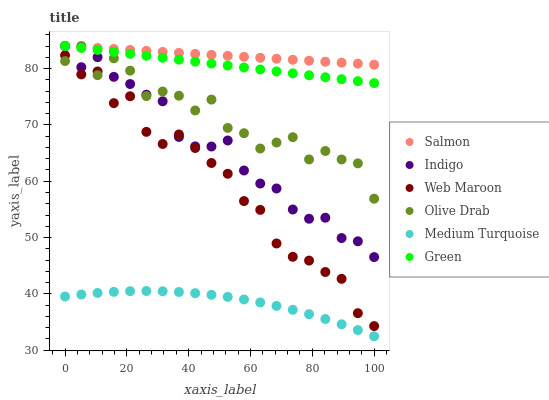Does Medium Turquoise have the minimum area under the curve?
Answer yes or no. Yes. Does Salmon have the maximum area under the curve?
Answer yes or no. Yes. Does Web Maroon have the minimum area under the curve?
Answer yes or no. No. Does Web Maroon have the maximum area under the curve?
Answer yes or no. No. Is Salmon the smoothest?
Answer yes or no. Yes. Is Olive Drab the roughest?
Answer yes or no. Yes. Is Web Maroon the smoothest?
Answer yes or no. No. Is Web Maroon the roughest?
Answer yes or no. No. Does Medium Turquoise have the lowest value?
Answer yes or no. Yes. Does Web Maroon have the lowest value?
Answer yes or no. No. Does Olive Drab have the highest value?
Answer yes or no. Yes. Does Web Maroon have the highest value?
Answer yes or no. No. Is Web Maroon less than Salmon?
Answer yes or no. Yes. Is Green greater than Medium Turquoise?
Answer yes or no. Yes. Does Salmon intersect Indigo?
Answer yes or no. Yes. Is Salmon less than Indigo?
Answer yes or no. No. Is Salmon greater than Indigo?
Answer yes or no. No. Does Web Maroon intersect Salmon?
Answer yes or no. No. 